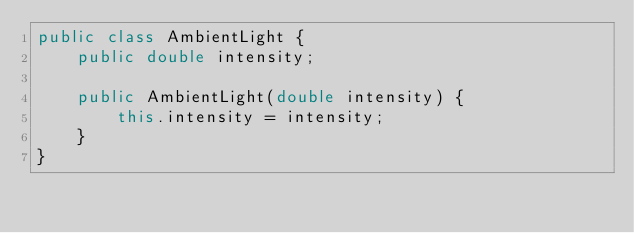Convert code to text. <code><loc_0><loc_0><loc_500><loc_500><_Java_>public class AmbientLight {
    public double intensity;

    public AmbientLight(double intensity) {
        this.intensity = intensity;
    }
}</code> 